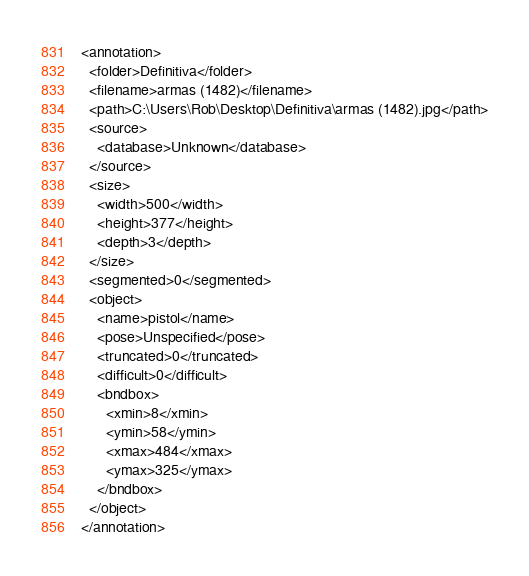<code> <loc_0><loc_0><loc_500><loc_500><_XML_><annotation>
  <folder>Definitiva</folder>
  <filename>armas (1482)</filename>
  <path>C:\Users\Rob\Desktop\Definitiva\armas (1482).jpg</path>
  <source>
    <database>Unknown</database>
  </source>
  <size>
    <width>500</width>
    <height>377</height>
    <depth>3</depth>
  </size>
  <segmented>0</segmented>
  <object>
    <name>pistol</name>
    <pose>Unspecified</pose>
    <truncated>0</truncated>
    <difficult>0</difficult>
    <bndbox>
      <xmin>8</xmin>
      <ymin>58</ymin>
      <xmax>484</xmax>
      <ymax>325</ymax>
    </bndbox>
  </object>
</annotation>
</code> 